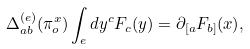Convert formula to latex. <formula><loc_0><loc_0><loc_500><loc_500>\Delta _ { a b } ^ { ( e ) } ( \pi _ { o } ^ { x } ) \int _ { e } d y ^ { c } F _ { c } ( y ) = \partial _ { [ a } F _ { b ] } ( x ) ,</formula> 